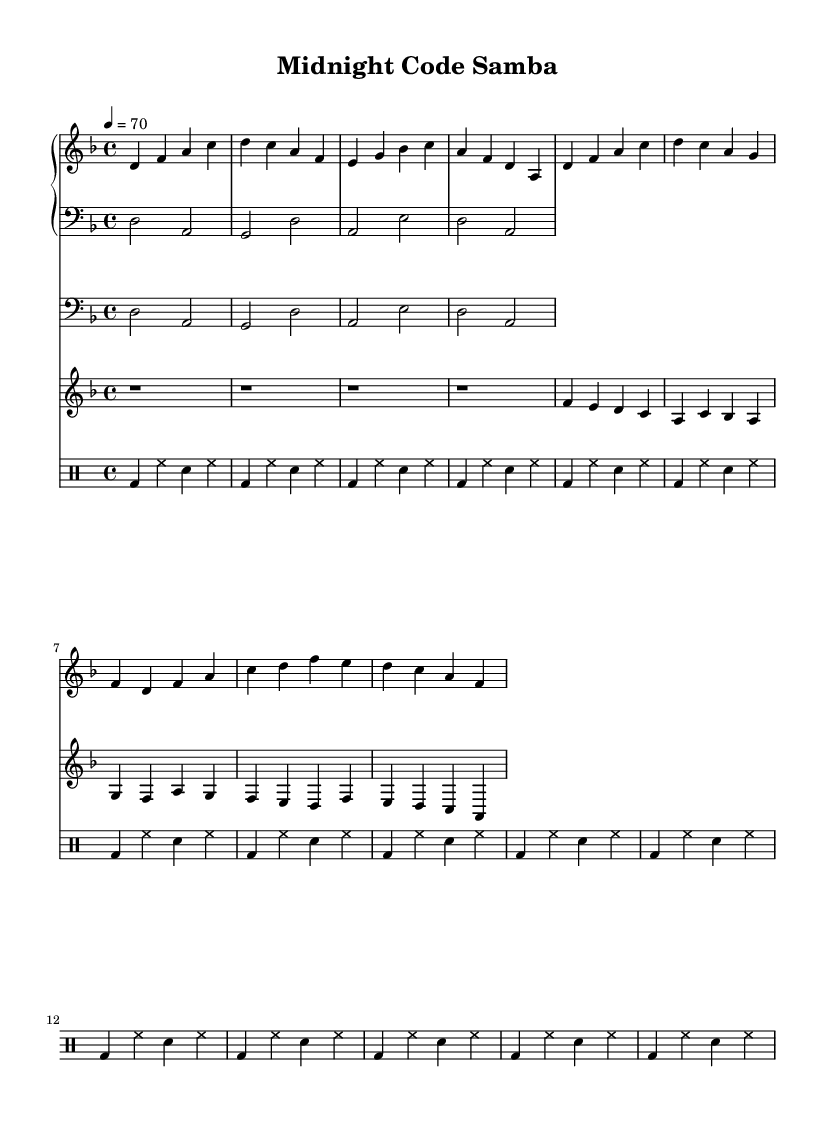What is the key signature of this music? The key signature is D minor, as indicated by the one flat (B flat) in the key signature on the left side of the staff.
Answer: D minor What is the time signature of this music? The time signature shown in the music is 4/4, which is typically notated at the beginning of the staff and indicates four beats per measure.
Answer: 4/4 What is the tempo marking for this piece? The tempo marking states "4 = 70," which means there are 70 beats per minute, indicated by the quarter note.
Answer: 70 How many measures are in the piano part? Counting the bars in the piano part, there are 8 measures total, as each bar is separated and the music layout indicates 8 distinct sections.
Answer: 8 What is the melodic instrument featured prominently in the piece? The notable melodic instrument in this piece is the trumpet, as it presents a distinct melody line starting from the first measure.
Answer: Trumpet What type of rhythm pattern is used in the drums? The drum part uses a repeated rhythm pattern throughout, specifically a bass drum and snare drum combination that unfolds over the eight measures.
Answer: Bass and snare Which jazz style is this music primarily associated with? This music can be identified as Smooth Latin Jazz, characterized by its syncopated rhythms and relaxing vibe, well-suited for late-night sessions.
Answer: Smooth Latin Jazz 